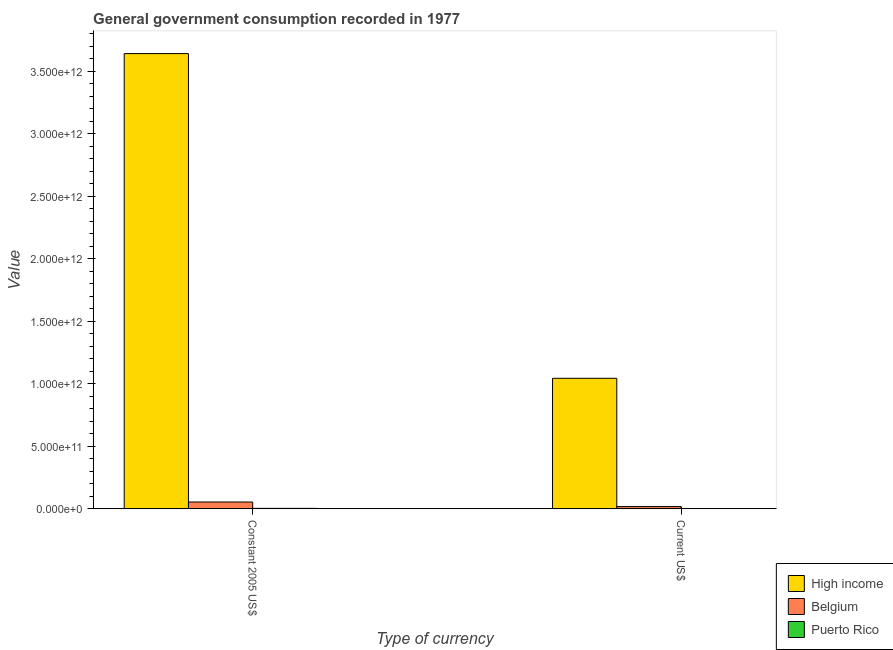How many groups of bars are there?
Your response must be concise. 2. How many bars are there on the 1st tick from the right?
Your response must be concise. 3. What is the label of the 2nd group of bars from the left?
Ensure brevity in your answer.  Current US$. What is the value consumed in constant 2005 us$ in Belgium?
Offer a very short reply. 5.47e+1. Across all countries, what is the maximum value consumed in constant 2005 us$?
Keep it short and to the point. 3.64e+12. Across all countries, what is the minimum value consumed in current us$?
Offer a very short reply. 1.73e+09. In which country was the value consumed in current us$ maximum?
Your answer should be very brief. High income. In which country was the value consumed in current us$ minimum?
Offer a terse response. Puerto Rico. What is the total value consumed in constant 2005 us$ in the graph?
Provide a short and direct response. 3.70e+12. What is the difference between the value consumed in constant 2005 us$ in Puerto Rico and that in Belgium?
Ensure brevity in your answer.  -5.08e+1. What is the difference between the value consumed in current us$ in Belgium and the value consumed in constant 2005 us$ in Puerto Rico?
Offer a very short reply. 1.42e+1. What is the average value consumed in constant 2005 us$ per country?
Make the answer very short. 1.23e+12. What is the difference between the value consumed in current us$ and value consumed in constant 2005 us$ in Belgium?
Your response must be concise. -3.66e+1. What is the ratio of the value consumed in constant 2005 us$ in High income to that in Puerto Rico?
Your answer should be very brief. 940.48. Is the value consumed in current us$ in High income less than that in Puerto Rico?
Make the answer very short. No. What does the 2nd bar from the left in Current US$ represents?
Give a very brief answer. Belgium. How many bars are there?
Keep it short and to the point. 6. Are all the bars in the graph horizontal?
Offer a terse response. No. How many countries are there in the graph?
Provide a short and direct response. 3. What is the difference between two consecutive major ticks on the Y-axis?
Ensure brevity in your answer.  5.00e+11. Where does the legend appear in the graph?
Give a very brief answer. Bottom right. What is the title of the graph?
Offer a very short reply. General government consumption recorded in 1977. Does "Suriname" appear as one of the legend labels in the graph?
Offer a terse response. No. What is the label or title of the X-axis?
Keep it short and to the point. Type of currency. What is the label or title of the Y-axis?
Give a very brief answer. Value. What is the Value in High income in Constant 2005 US$?
Provide a short and direct response. 3.64e+12. What is the Value in Belgium in Constant 2005 US$?
Ensure brevity in your answer.  5.47e+1. What is the Value of Puerto Rico in Constant 2005 US$?
Offer a very short reply. 3.87e+09. What is the Value of High income in Current US$?
Make the answer very short. 1.04e+12. What is the Value of Belgium in Current US$?
Your response must be concise. 1.80e+1. What is the Value in Puerto Rico in Current US$?
Your answer should be very brief. 1.73e+09. Across all Type of currency, what is the maximum Value in High income?
Your response must be concise. 3.64e+12. Across all Type of currency, what is the maximum Value in Belgium?
Make the answer very short. 5.47e+1. Across all Type of currency, what is the maximum Value of Puerto Rico?
Your response must be concise. 3.87e+09. Across all Type of currency, what is the minimum Value of High income?
Offer a terse response. 1.04e+12. Across all Type of currency, what is the minimum Value in Belgium?
Your answer should be compact. 1.80e+1. Across all Type of currency, what is the minimum Value in Puerto Rico?
Your answer should be compact. 1.73e+09. What is the total Value of High income in the graph?
Provide a succinct answer. 4.68e+12. What is the total Value in Belgium in the graph?
Provide a short and direct response. 7.27e+1. What is the total Value of Puerto Rico in the graph?
Make the answer very short. 5.60e+09. What is the difference between the Value of High income in Constant 2005 US$ and that in Current US$?
Provide a succinct answer. 2.60e+12. What is the difference between the Value in Belgium in Constant 2005 US$ and that in Current US$?
Keep it short and to the point. 3.66e+1. What is the difference between the Value of Puerto Rico in Constant 2005 US$ and that in Current US$?
Provide a short and direct response. 2.14e+09. What is the difference between the Value in High income in Constant 2005 US$ and the Value in Belgium in Current US$?
Make the answer very short. 3.62e+12. What is the difference between the Value in High income in Constant 2005 US$ and the Value in Puerto Rico in Current US$?
Keep it short and to the point. 3.64e+12. What is the difference between the Value of Belgium in Constant 2005 US$ and the Value of Puerto Rico in Current US$?
Your answer should be compact. 5.30e+1. What is the average Value in High income per Type of currency?
Keep it short and to the point. 2.34e+12. What is the average Value of Belgium per Type of currency?
Provide a short and direct response. 3.64e+1. What is the average Value of Puerto Rico per Type of currency?
Make the answer very short. 2.80e+09. What is the difference between the Value in High income and Value in Belgium in Constant 2005 US$?
Provide a short and direct response. 3.58e+12. What is the difference between the Value of High income and Value of Puerto Rico in Constant 2005 US$?
Your answer should be compact. 3.64e+12. What is the difference between the Value of Belgium and Value of Puerto Rico in Constant 2005 US$?
Give a very brief answer. 5.08e+1. What is the difference between the Value in High income and Value in Belgium in Current US$?
Your answer should be very brief. 1.03e+12. What is the difference between the Value of High income and Value of Puerto Rico in Current US$?
Offer a terse response. 1.04e+12. What is the difference between the Value in Belgium and Value in Puerto Rico in Current US$?
Offer a very short reply. 1.63e+1. What is the ratio of the Value of High income in Constant 2005 US$ to that in Current US$?
Offer a terse response. 3.49. What is the ratio of the Value of Belgium in Constant 2005 US$ to that in Current US$?
Your answer should be very brief. 3.03. What is the ratio of the Value of Puerto Rico in Constant 2005 US$ to that in Current US$?
Ensure brevity in your answer.  2.24. What is the difference between the highest and the second highest Value in High income?
Your answer should be compact. 2.60e+12. What is the difference between the highest and the second highest Value in Belgium?
Ensure brevity in your answer.  3.66e+1. What is the difference between the highest and the second highest Value in Puerto Rico?
Your response must be concise. 2.14e+09. What is the difference between the highest and the lowest Value of High income?
Offer a terse response. 2.60e+12. What is the difference between the highest and the lowest Value of Belgium?
Offer a terse response. 3.66e+1. What is the difference between the highest and the lowest Value in Puerto Rico?
Your response must be concise. 2.14e+09. 